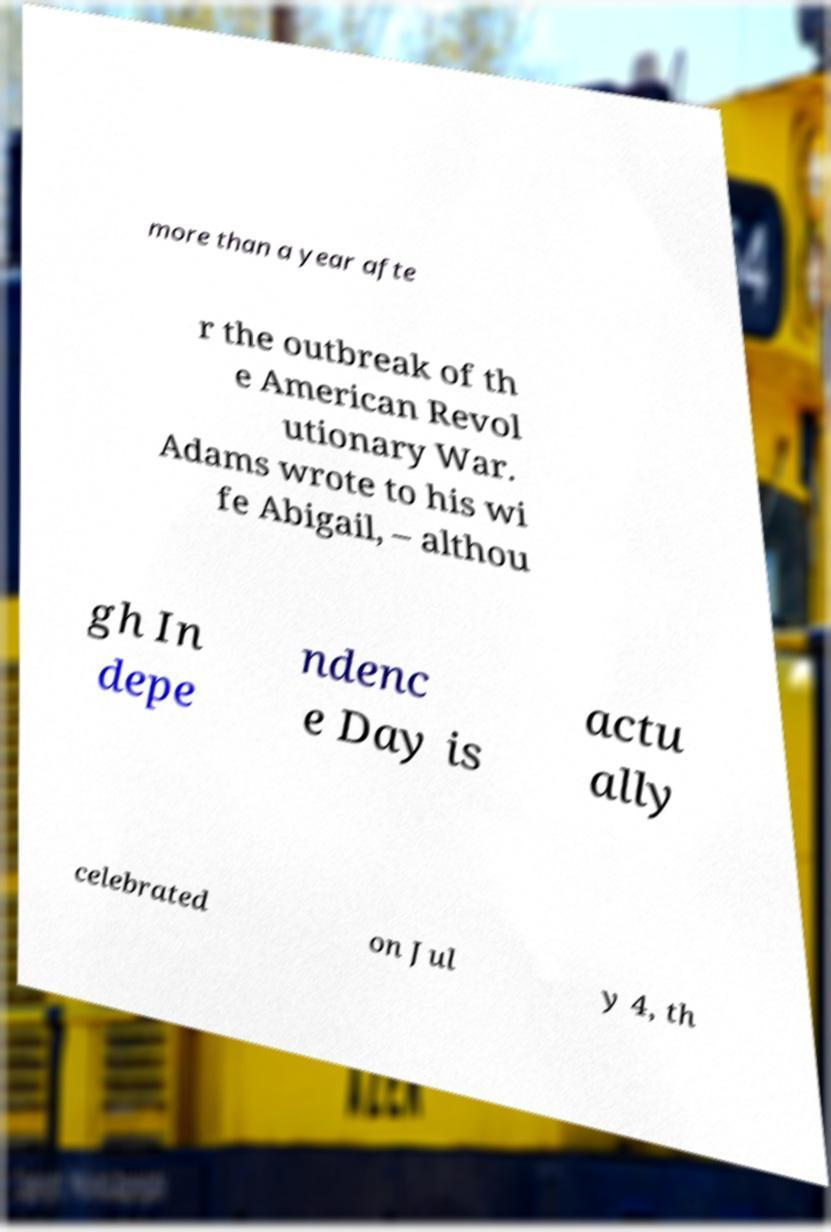Can you read and provide the text displayed in the image?This photo seems to have some interesting text. Can you extract and type it out for me? more than a year afte r the outbreak of th e American Revol utionary War. Adams wrote to his wi fe Abigail, – althou gh In depe ndenc e Day is actu ally celebrated on Jul y 4, th 